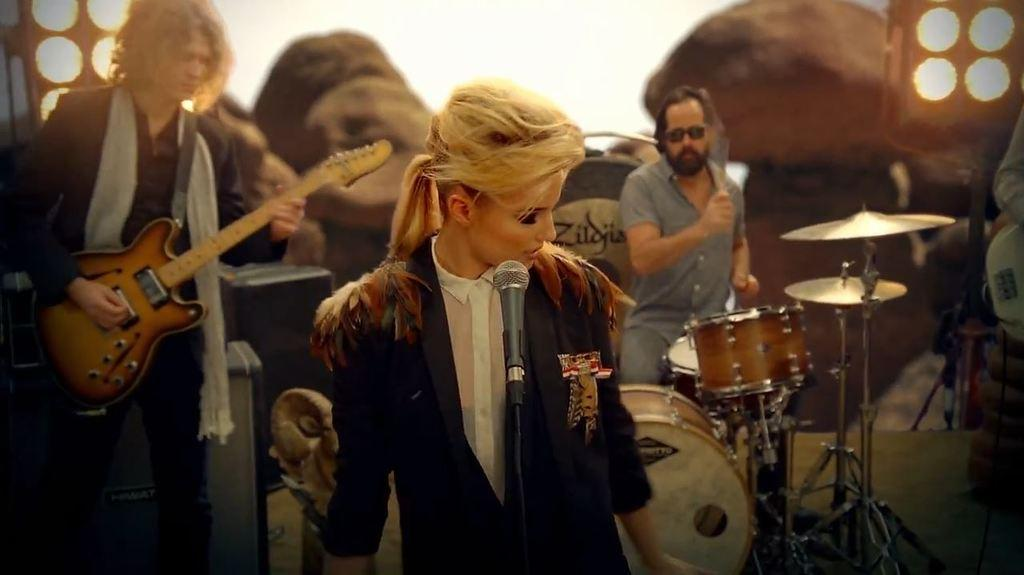How many people are playing musical instruments in the image? There are three people playing musical instruments in the image. What is the lady in the image doing? The lady is singing in a mic. What can be seen in the background of the image? There are lights and rocks in the background. What type of leather is being used to make the instruments in the image? There is no leather mentioned or visible in the image; the instruments are not described in detail. 